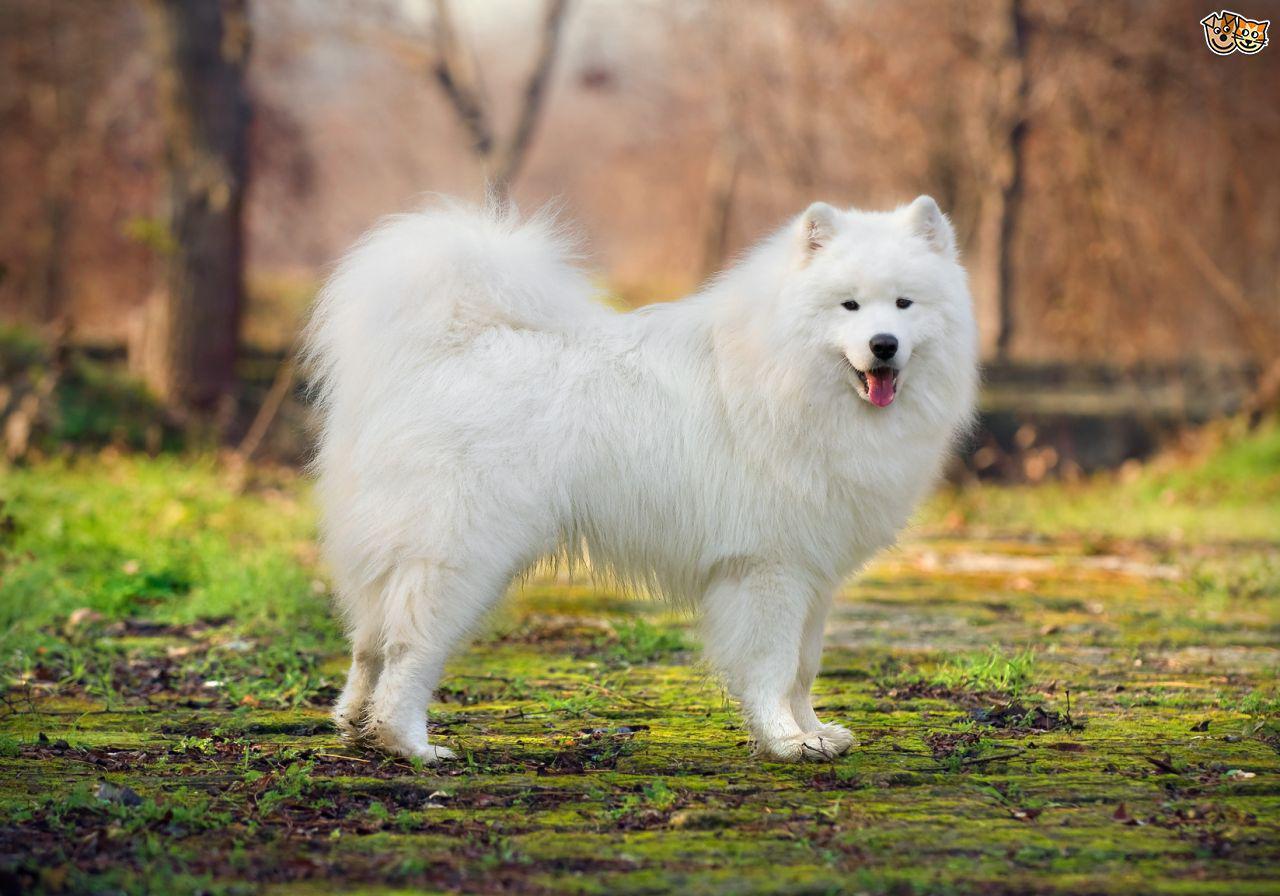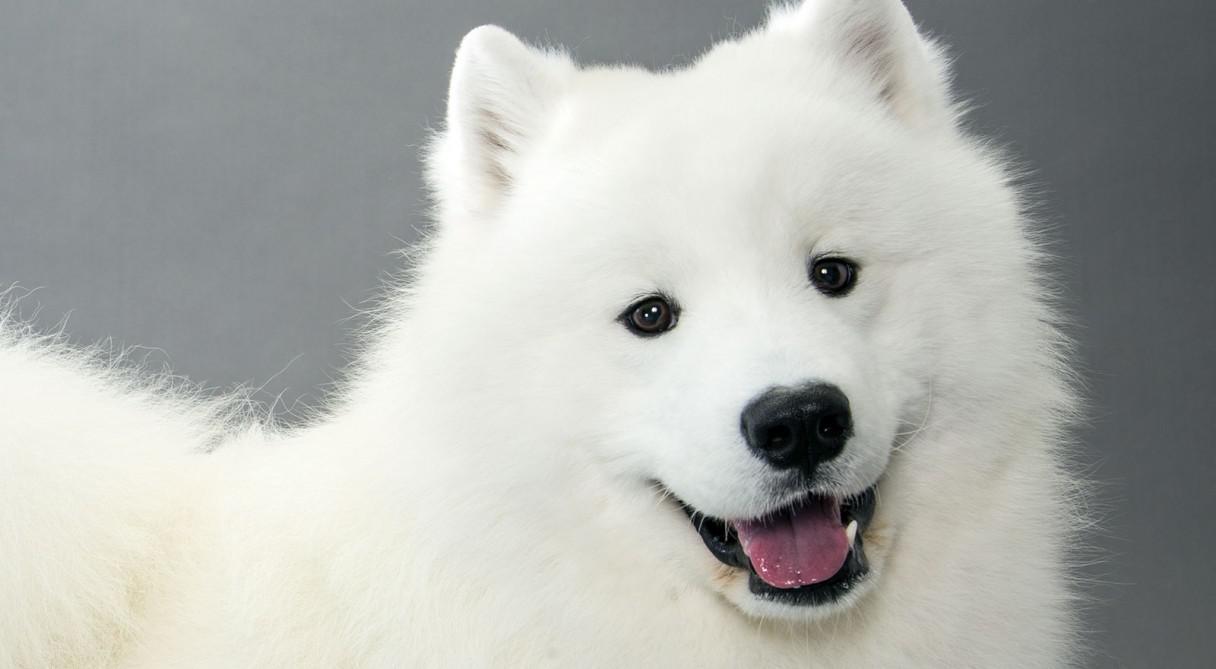The first image is the image on the left, the second image is the image on the right. Evaluate the accuracy of this statement regarding the images: "The dogs have their mouths open.". Is it true? Answer yes or no. Yes. 